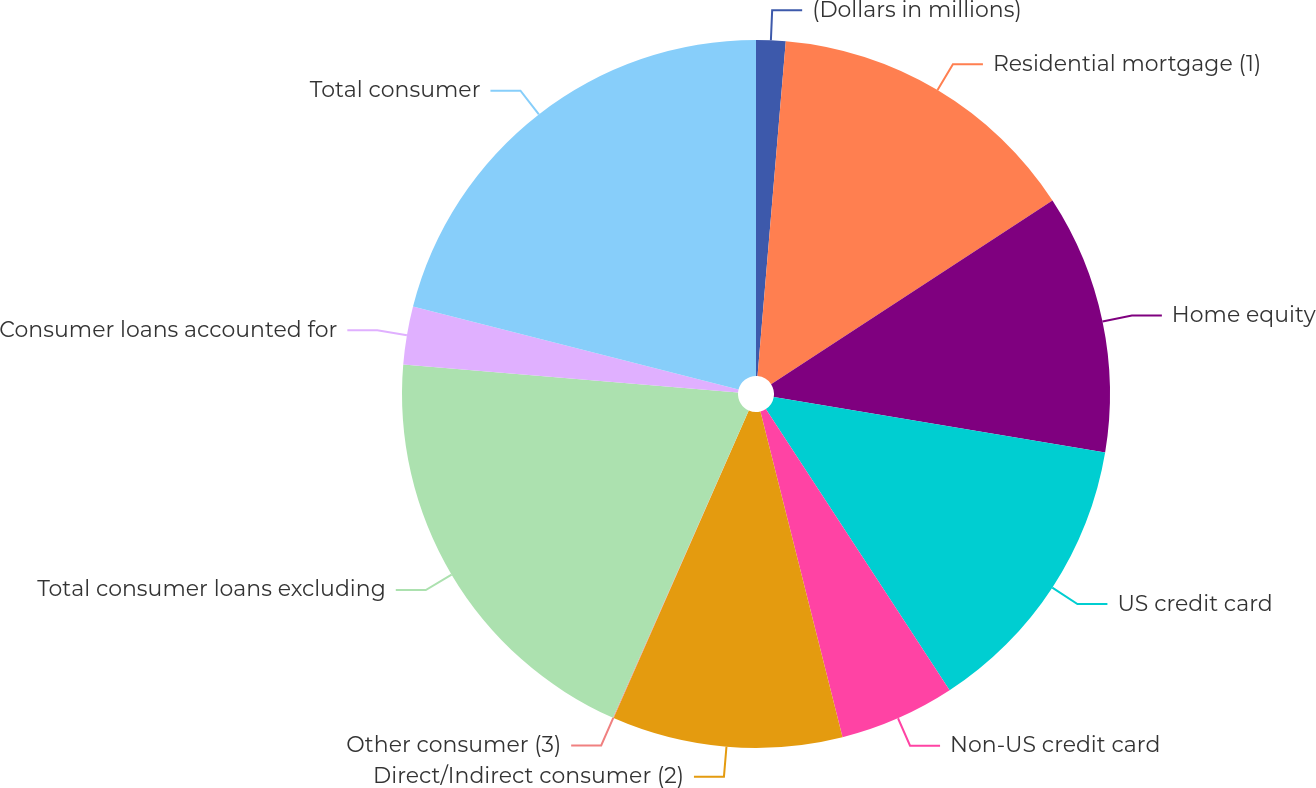Convert chart to OTSL. <chart><loc_0><loc_0><loc_500><loc_500><pie_chart><fcel>(Dollars in millions)<fcel>Residential mortgage (1)<fcel>Home equity<fcel>US credit card<fcel>Non-US credit card<fcel>Direct/Indirect consumer (2)<fcel>Other consumer (3)<fcel>Total consumer loans excluding<fcel>Consumer loans accounted for<fcel>Total consumer<nl><fcel>1.34%<fcel>14.46%<fcel>11.84%<fcel>13.15%<fcel>5.28%<fcel>10.52%<fcel>0.03%<fcel>19.71%<fcel>2.65%<fcel>21.02%<nl></chart> 